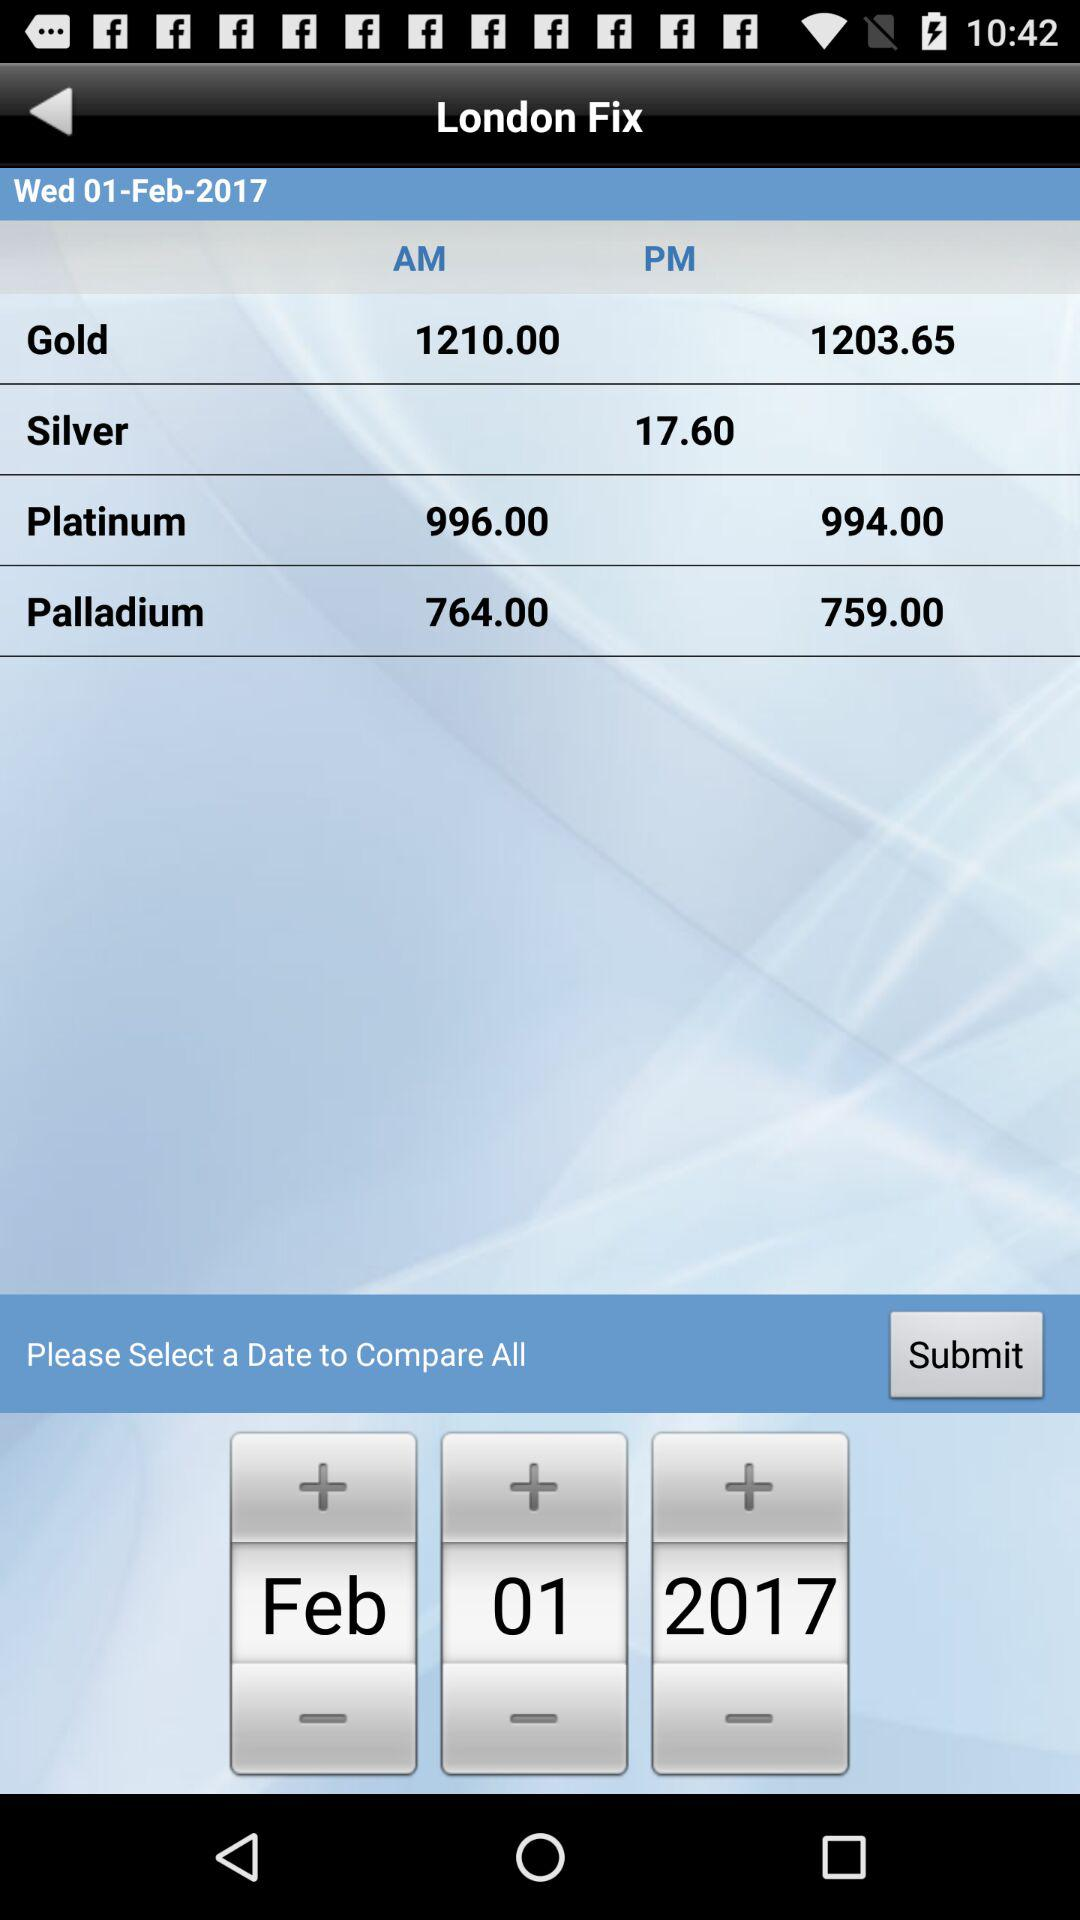What is the price of gold? The prices of gold are 1210.00 and 1203.65. 